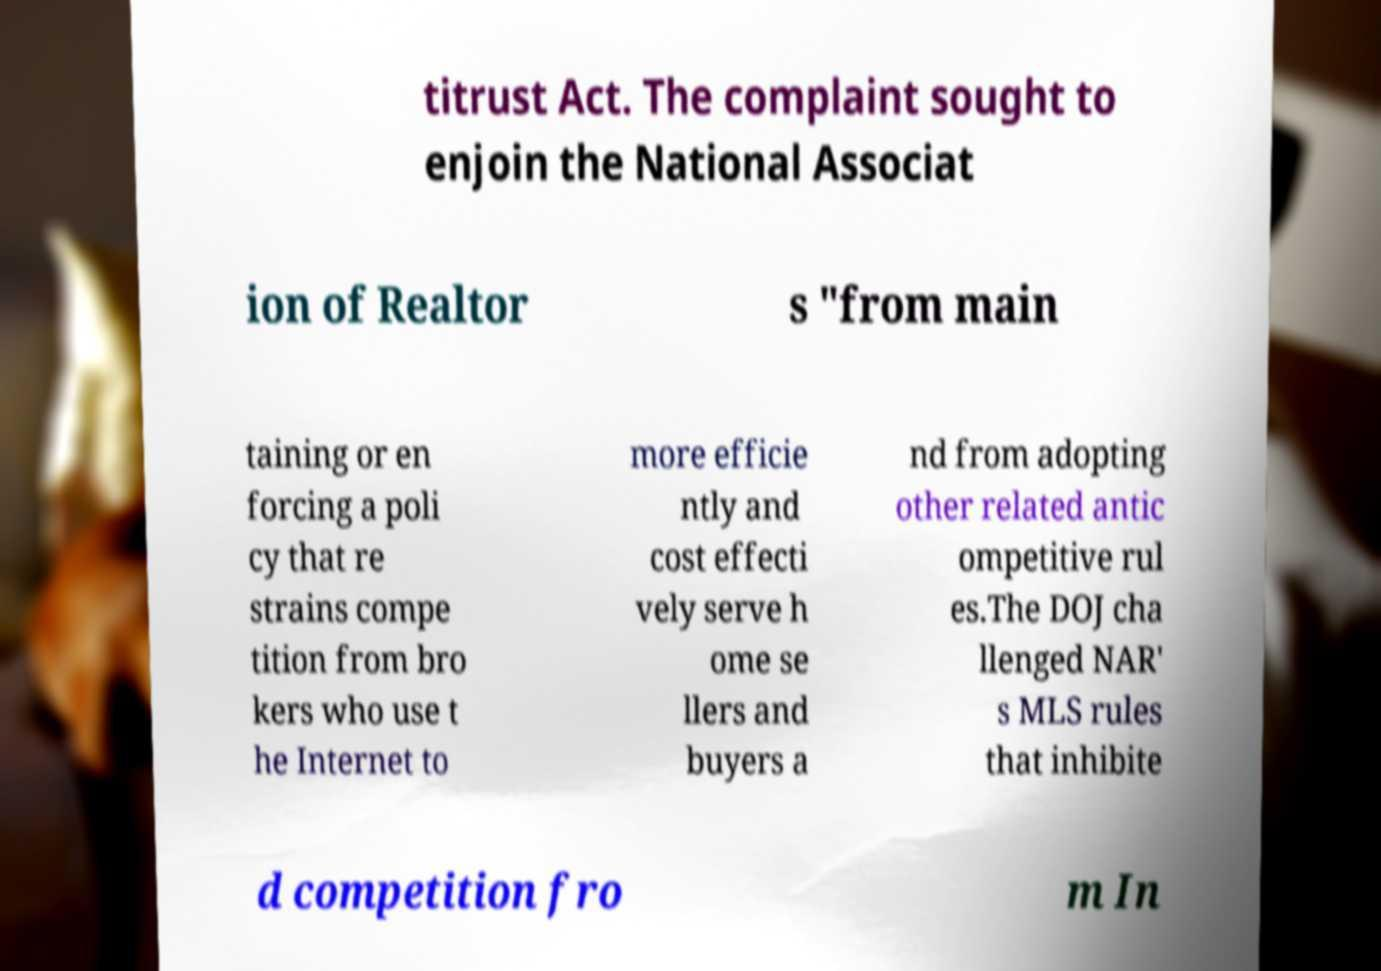Please read and relay the text visible in this image. What does it say? titrust Act. The complaint sought to enjoin the National Associat ion of Realtor s "from main taining or en forcing a poli cy that re strains compe tition from bro kers who use t he Internet to more efficie ntly and cost effecti vely serve h ome se llers and buyers a nd from adopting other related antic ompetitive rul es.The DOJ cha llenged NAR' s MLS rules that inhibite d competition fro m In 